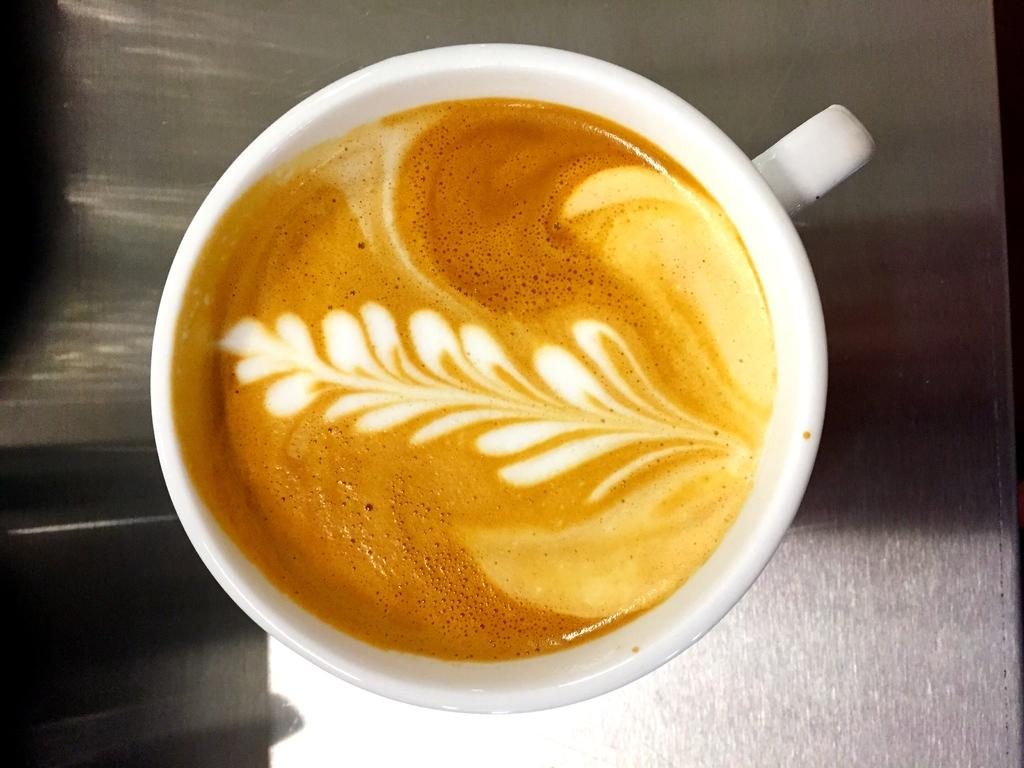What is the main object in the center of the image? There is a teacup in the center of the image. Can you describe the teacup in more detail? Unfortunately, the facts provided do not give any additional details about the teacup. What type of tools does the carpenter use in the image? There is no carpenter present in the image, so it is not possible to answer that question. 